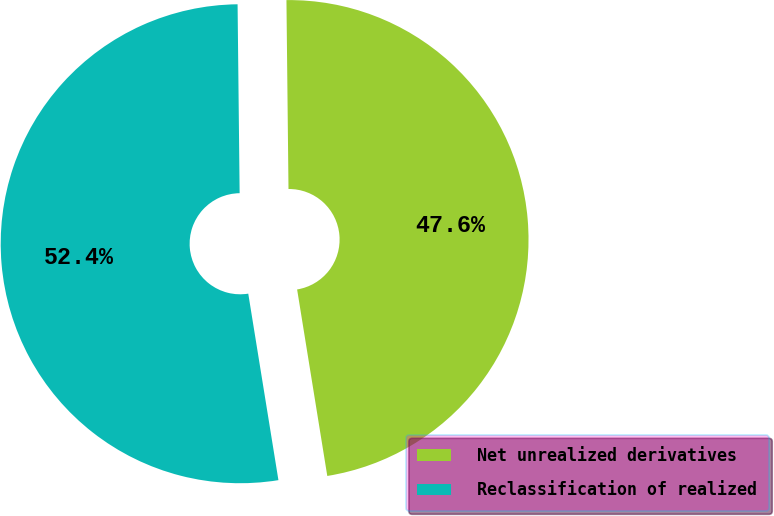<chart> <loc_0><loc_0><loc_500><loc_500><pie_chart><fcel>Net unrealized derivatives<fcel>Reclassification of realized<nl><fcel>47.62%<fcel>52.38%<nl></chart> 